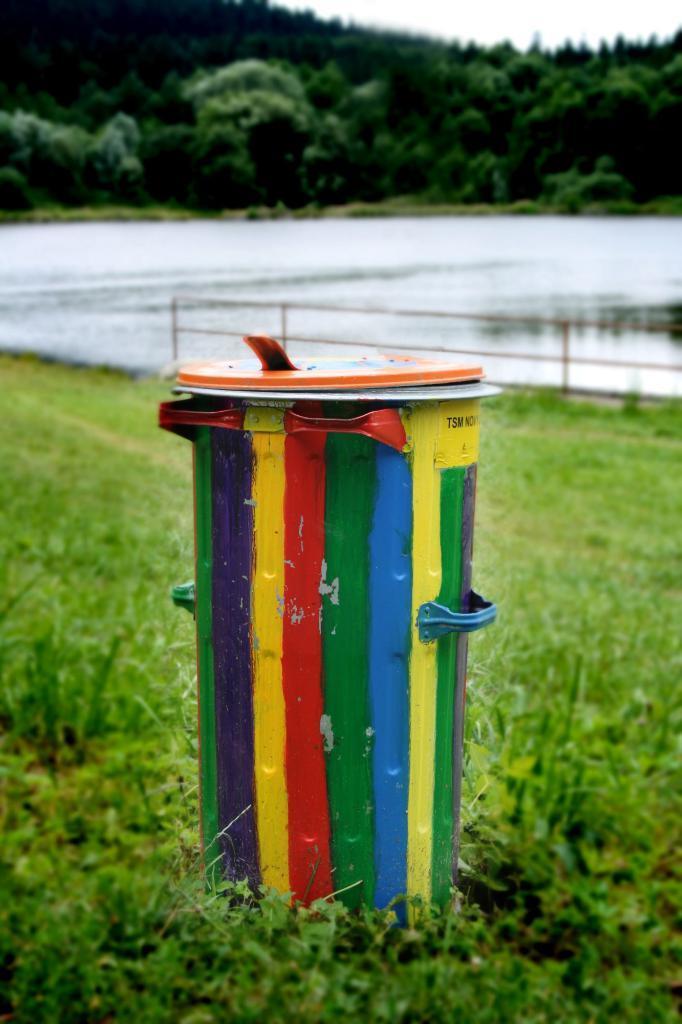Please provide a concise description of this image. In this picture we can see a box in the front, at the bottom we can see grass, there is water in the middle, in the background there are some trees, we can see the sky at the top of the picture. 